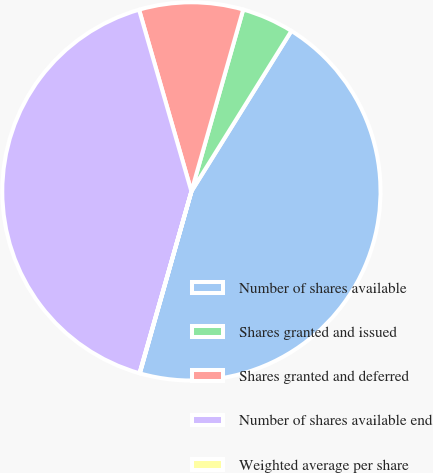Convert chart to OTSL. <chart><loc_0><loc_0><loc_500><loc_500><pie_chart><fcel>Number of shares available<fcel>Shares granted and issued<fcel>Shares granted and deferred<fcel>Number of shares available end<fcel>Weighted average per share<nl><fcel>45.53%<fcel>4.45%<fcel>8.88%<fcel>41.11%<fcel>0.03%<nl></chart> 